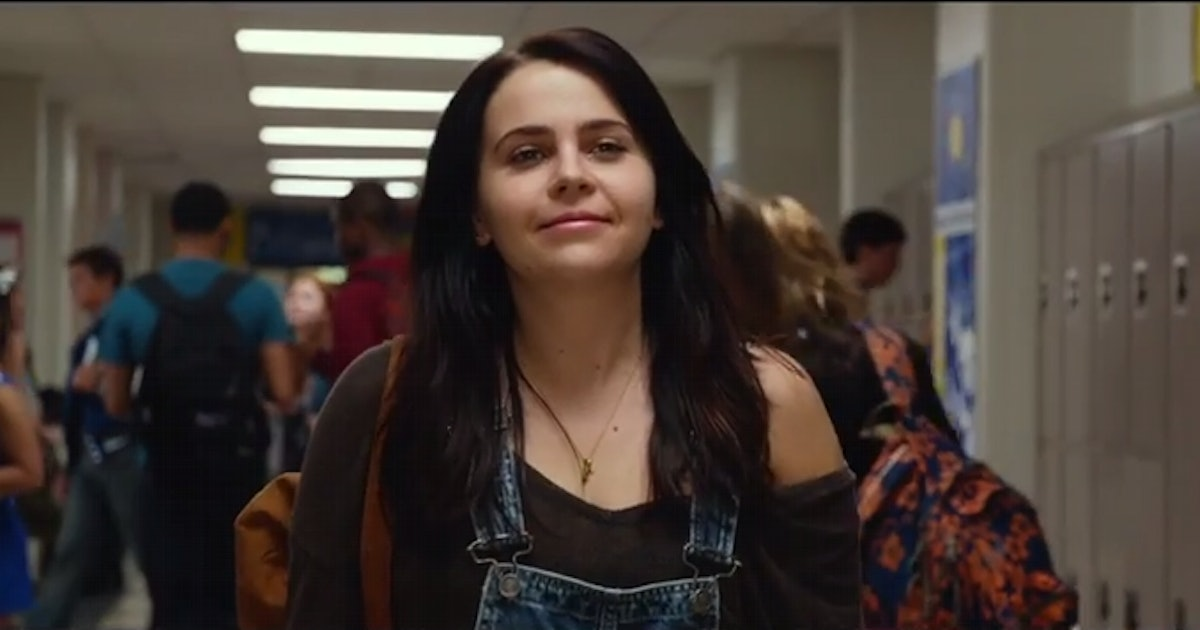Can you create another realistic scenario for this character? Sure! Mia is on her way to meet her friends for lunch in the school cafeteria. As she walks, she flips through the messages on her phone, organizing plans for after school. They plan to study together for the upcoming exams and hang out at the local coffee shop. As she reaches the cafeteria, she sees her friends waving from their favorite table near the window, the sunlight streaming in and illuminating their cheerful faces. Mia smiles and heads over, looking forward to a break from her busy day. 